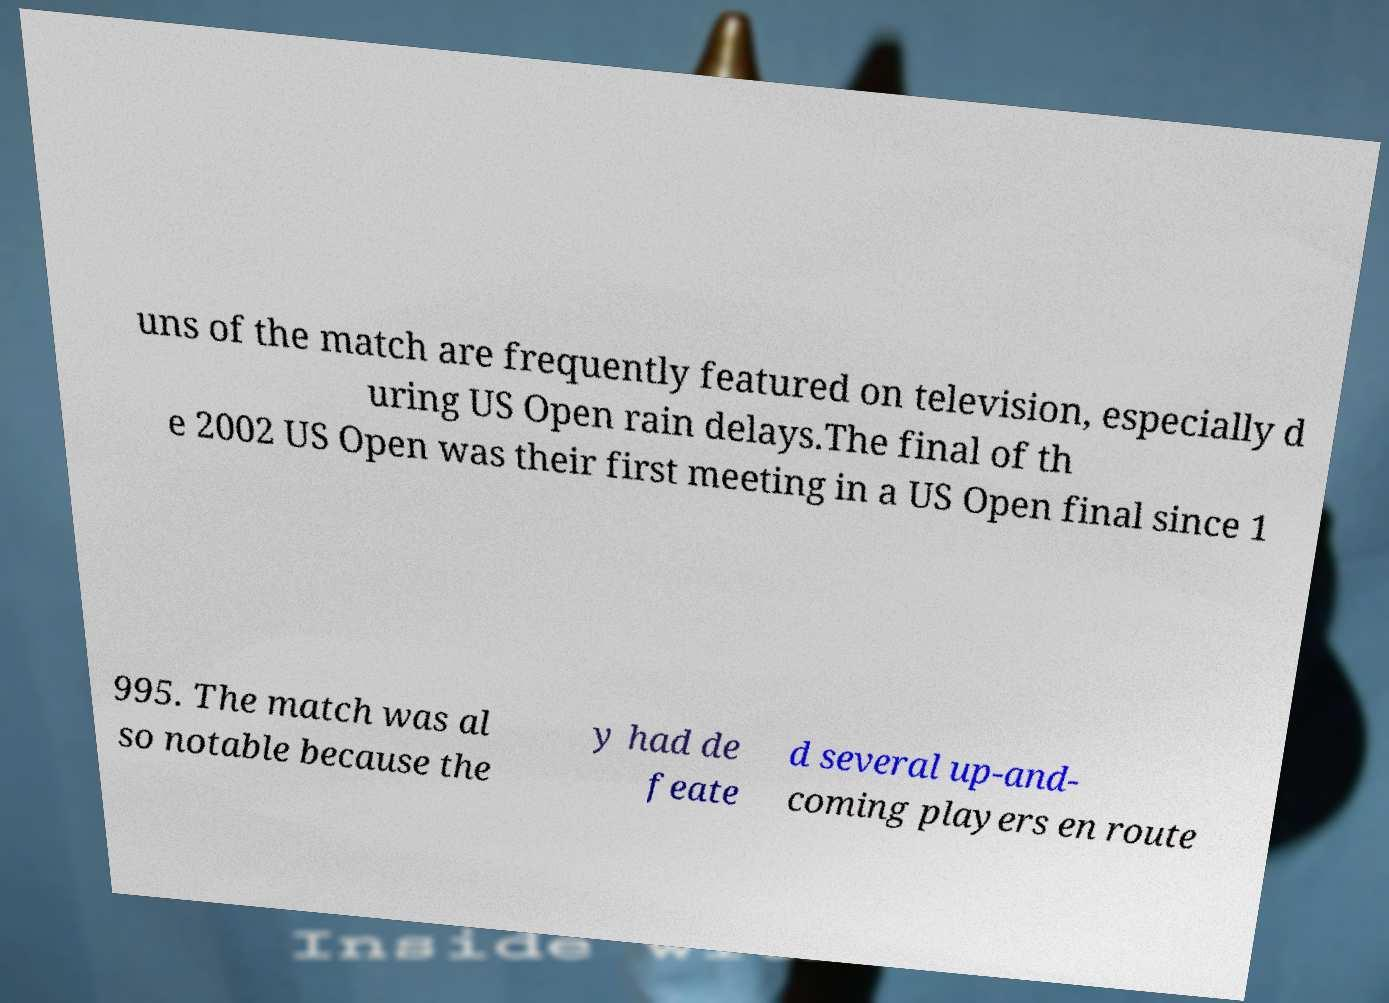Please identify and transcribe the text found in this image. uns of the match are frequently featured on television, especially d uring US Open rain delays.The final of th e 2002 US Open was their first meeting in a US Open final since 1 995. The match was al so notable because the y had de feate d several up-and- coming players en route 